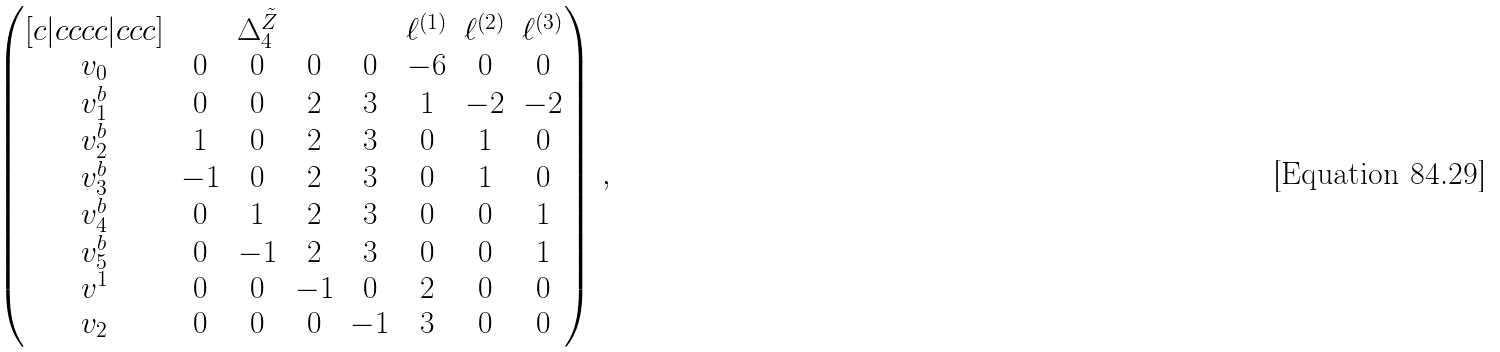Convert formula to latex. <formula><loc_0><loc_0><loc_500><loc_500>\begin{pmatrix} [ c | c c c c | c c c ] & & \Delta _ { 4 } ^ { \tilde { Z } } & & & \ell ^ { ( 1 ) } & \ell ^ { ( 2 ) } & \ell ^ { ( 3 ) } \\ v _ { 0 } & 0 & 0 & 0 & 0 & - 6 & 0 & 0 \\ v ^ { b } _ { 1 } & 0 & 0 & 2 & 3 & 1 & - 2 & - 2 \\ v ^ { b } _ { 2 } & 1 & 0 & 2 & 3 & 0 & 1 & 0 \\ v ^ { b } _ { 3 } & - 1 & 0 & 2 & 3 & 0 & 1 & 0 \\ v ^ { b } _ { 4 } & 0 & 1 & 2 & 3 & 0 & 0 & 1 \\ v ^ { b } _ { 5 } & 0 & - 1 & 2 & 3 & 0 & 0 & 1 \\ v ^ { 1 } & 0 & 0 & - 1 & 0 & 2 & 0 & 0 \\ v _ { 2 } & 0 & 0 & 0 & - 1 & 3 & 0 & 0 \end{pmatrix} \, ,</formula> 